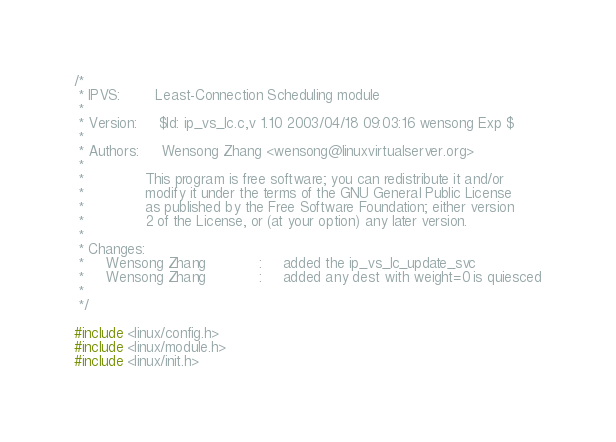Convert code to text. <code><loc_0><loc_0><loc_500><loc_500><_C_>/*
 * IPVS:        Least-Connection Scheduling module
 *
 * Version:     $Id: ip_vs_lc.c,v 1.10 2003/04/18 09:03:16 wensong Exp $
 *
 * Authors:     Wensong Zhang <wensong@linuxvirtualserver.org>
 *
 *              This program is free software; you can redistribute it and/or
 *              modify it under the terms of the GNU General Public License
 *              as published by the Free Software Foundation; either version
 *              2 of the License, or (at your option) any later version.
 *
 * Changes:
 *     Wensong Zhang            :     added the ip_vs_lc_update_svc
 *     Wensong Zhang            :     added any dest with weight=0 is quiesced
 *
 */

#include <linux/config.h>
#include <linux/module.h>
#include <linux/init.h></code> 